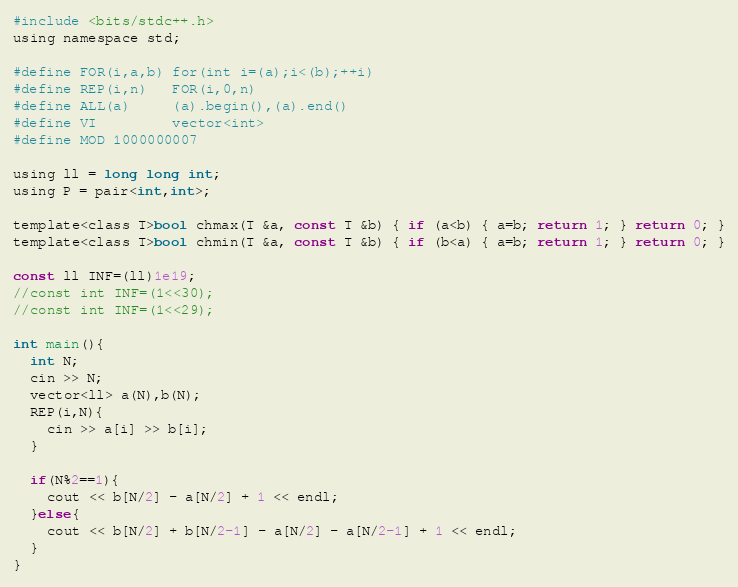Convert code to text. <code><loc_0><loc_0><loc_500><loc_500><_C_>#include <bits/stdc++.h>
using namespace std;

#define FOR(i,a,b) for(int i=(a);i<(b);++i)
#define REP(i,n)   FOR(i,0,n)
#define ALL(a)     (a).begin(),(a).end()
#define VI         vector<int>
#define MOD 1000000007

using ll = long long int;
using P = pair<int,int>;

template<class T>bool chmax(T &a, const T &b) { if (a<b) { a=b; return 1; } return 0; }
template<class T>bool chmin(T &a, const T &b) { if (b<a) { a=b; return 1; } return 0; }

const ll INF=(ll)1e19;
//const int INF=(1<<30);
//const int INF=(1<<29);

int main(){
  int N;
  cin >> N;
  vector<ll> a(N),b(N);
  REP(i,N){
    cin >> a[i] >> b[i];
  }

  if(N%2==1){
    cout << b[N/2] - a[N/2] + 1 << endl;
  }else{
    cout << b[N/2] + b[N/2-1] - a[N/2] - a[N/2-1] + 1 << endl;
  }
}

</code> 